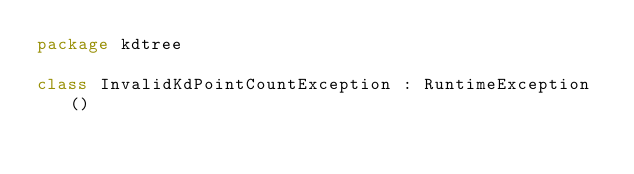<code> <loc_0><loc_0><loc_500><loc_500><_Kotlin_>package kdtree

class InvalidKdPointCountException : RuntimeException()</code> 